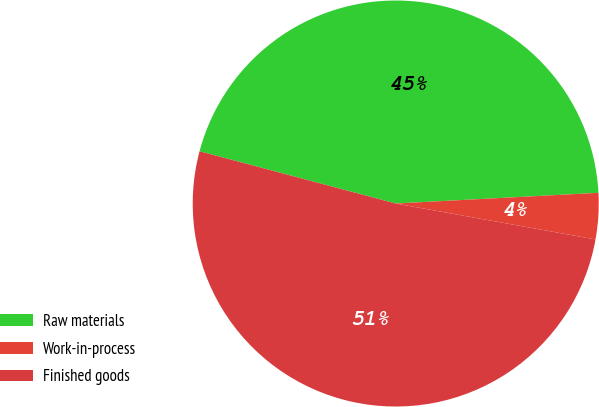Convert chart. <chart><loc_0><loc_0><loc_500><loc_500><pie_chart><fcel>Raw materials<fcel>Work-in-process<fcel>Finished goods<nl><fcel>45.02%<fcel>3.67%<fcel>51.31%<nl></chart> 